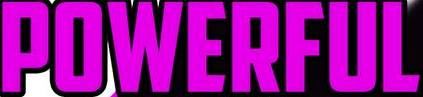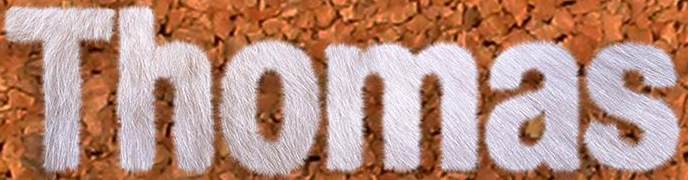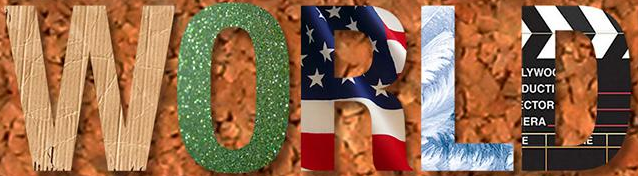What text appears in these images from left to right, separated by a semicolon? POWERFUL; Thomas; WORLD 